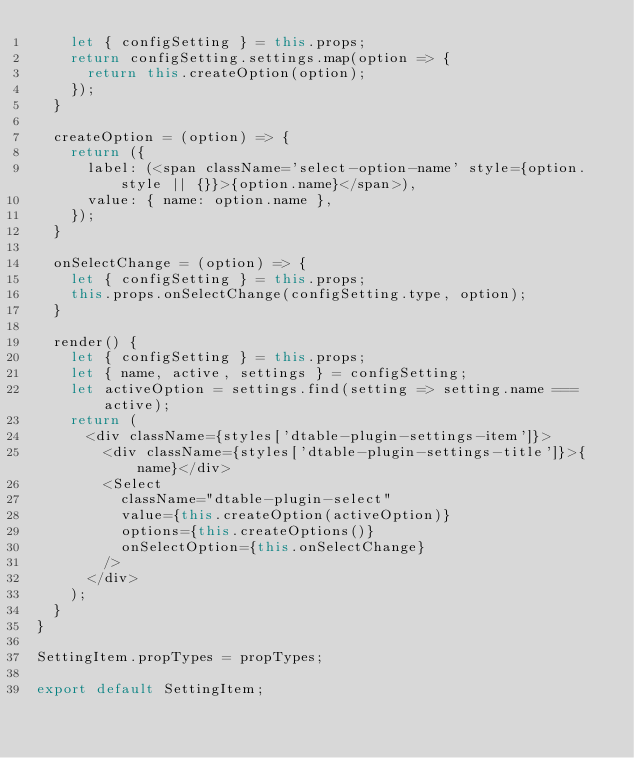<code> <loc_0><loc_0><loc_500><loc_500><_JavaScript_>    let { configSetting } = this.props;
    return configSetting.settings.map(option => {
      return this.createOption(option);
    });
  }

  createOption = (option) => {
    return ({
      label: (<span className='select-option-name' style={option.style || {}}>{option.name}</span>),
      value: { name: option.name },
    });
  }

  onSelectChange = (option) => {
    let { configSetting } = this.props;
    this.props.onSelectChange(configSetting.type, option);
  }

  render() {
    let { configSetting } = this.props;
    let { name, active, settings } = configSetting;
    let activeOption = settings.find(setting => setting.name === active);
    return (
      <div className={styles['dtable-plugin-settings-item']}>
        <div className={styles['dtable-plugin-settings-title']}>{name}</div>
        <Select
          className="dtable-plugin-select"
          value={this.createOption(activeOption)}
          options={this.createOptions()}
          onSelectOption={this.onSelectChange}
        />
      </div>
    );
  }
}

SettingItem.propTypes = propTypes;

export default SettingItem;
</code> 